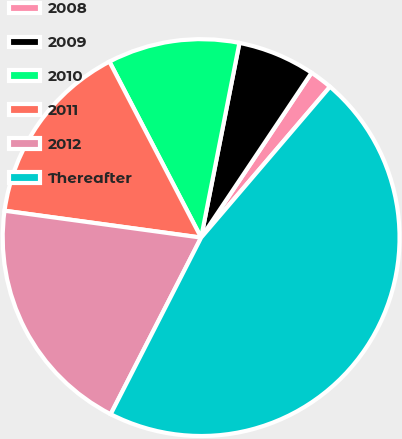Convert chart to OTSL. <chart><loc_0><loc_0><loc_500><loc_500><pie_chart><fcel>2008<fcel>2009<fcel>2010<fcel>2011<fcel>2012<fcel>Thereafter<nl><fcel>1.86%<fcel>6.3%<fcel>10.74%<fcel>15.19%<fcel>19.63%<fcel>46.28%<nl></chart> 